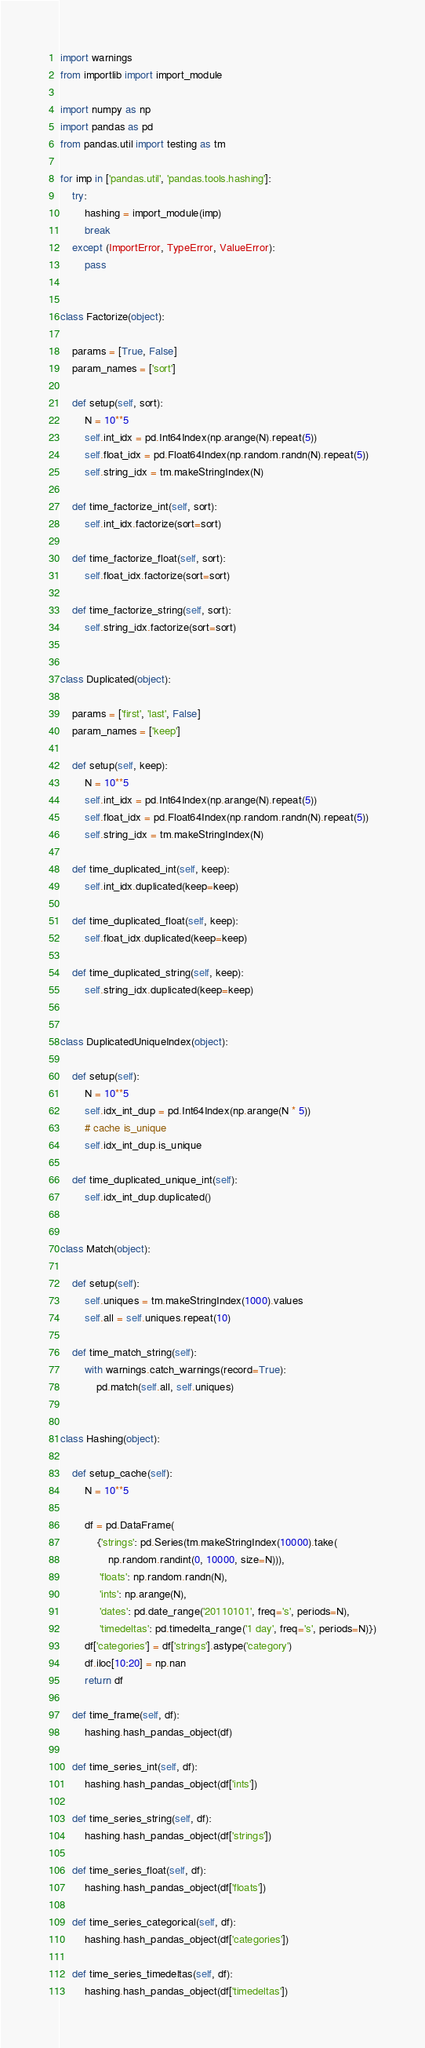Convert code to text. <code><loc_0><loc_0><loc_500><loc_500><_Python_>import warnings
from importlib import import_module

import numpy as np
import pandas as pd
from pandas.util import testing as tm

for imp in ['pandas.util', 'pandas.tools.hashing']:
    try:
        hashing = import_module(imp)
        break
    except (ImportError, TypeError, ValueError):
        pass


class Factorize(object):

    params = [True, False]
    param_names = ['sort']

    def setup(self, sort):
        N = 10**5
        self.int_idx = pd.Int64Index(np.arange(N).repeat(5))
        self.float_idx = pd.Float64Index(np.random.randn(N).repeat(5))
        self.string_idx = tm.makeStringIndex(N)

    def time_factorize_int(self, sort):
        self.int_idx.factorize(sort=sort)

    def time_factorize_float(self, sort):
        self.float_idx.factorize(sort=sort)

    def time_factorize_string(self, sort):
        self.string_idx.factorize(sort=sort)


class Duplicated(object):

    params = ['first', 'last', False]
    param_names = ['keep']

    def setup(self, keep):
        N = 10**5
        self.int_idx = pd.Int64Index(np.arange(N).repeat(5))
        self.float_idx = pd.Float64Index(np.random.randn(N).repeat(5))
        self.string_idx = tm.makeStringIndex(N)

    def time_duplicated_int(self, keep):
        self.int_idx.duplicated(keep=keep)

    def time_duplicated_float(self, keep):
        self.float_idx.duplicated(keep=keep)

    def time_duplicated_string(self, keep):
        self.string_idx.duplicated(keep=keep)


class DuplicatedUniqueIndex(object):

    def setup(self):
        N = 10**5
        self.idx_int_dup = pd.Int64Index(np.arange(N * 5))
        # cache is_unique
        self.idx_int_dup.is_unique

    def time_duplicated_unique_int(self):
        self.idx_int_dup.duplicated()


class Match(object):

    def setup(self):
        self.uniques = tm.makeStringIndex(1000).values
        self.all = self.uniques.repeat(10)

    def time_match_string(self):
        with warnings.catch_warnings(record=True):
            pd.match(self.all, self.uniques)


class Hashing(object):

    def setup_cache(self):
        N = 10**5

        df = pd.DataFrame(
            {'strings': pd.Series(tm.makeStringIndex(10000).take(
                np.random.randint(0, 10000, size=N))),
             'floats': np.random.randn(N),
             'ints': np.arange(N),
             'dates': pd.date_range('20110101', freq='s', periods=N),
             'timedeltas': pd.timedelta_range('1 day', freq='s', periods=N)})
        df['categories'] = df['strings'].astype('category')
        df.iloc[10:20] = np.nan
        return df

    def time_frame(self, df):
        hashing.hash_pandas_object(df)

    def time_series_int(self, df):
        hashing.hash_pandas_object(df['ints'])

    def time_series_string(self, df):
        hashing.hash_pandas_object(df['strings'])

    def time_series_float(self, df):
        hashing.hash_pandas_object(df['floats'])

    def time_series_categorical(self, df):
        hashing.hash_pandas_object(df['categories'])

    def time_series_timedeltas(self, df):
        hashing.hash_pandas_object(df['timedeltas'])
</code> 